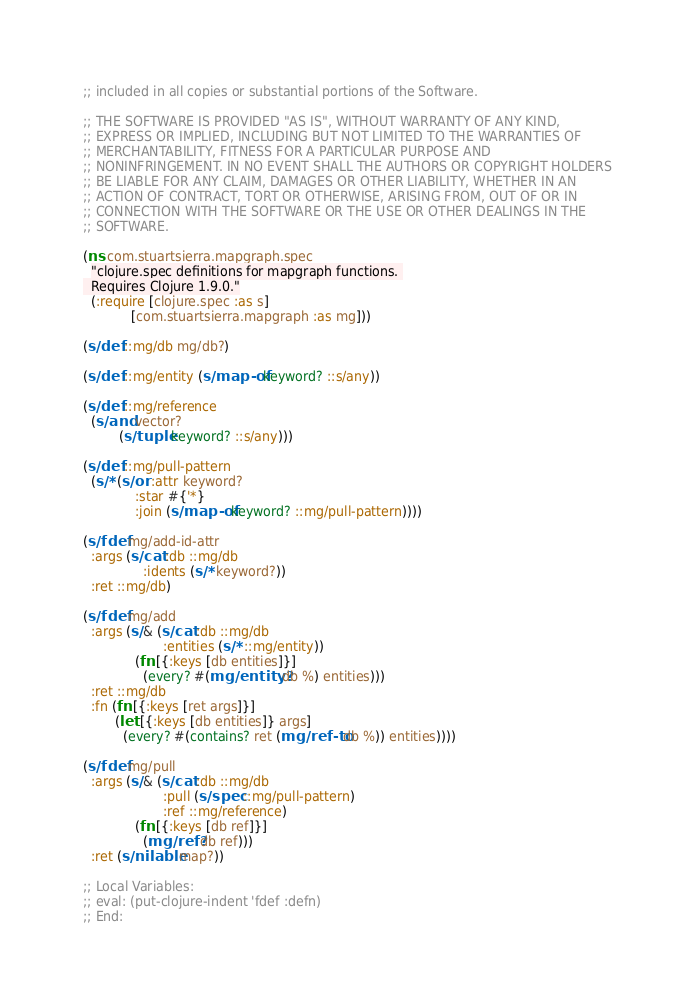<code> <loc_0><loc_0><loc_500><loc_500><_Clojure_>;; included in all copies or substantial portions of the Software.

;; THE SOFTWARE IS PROVIDED "AS IS", WITHOUT WARRANTY OF ANY KIND,
;; EXPRESS OR IMPLIED, INCLUDING BUT NOT LIMITED TO THE WARRANTIES OF
;; MERCHANTABILITY, FITNESS FOR A PARTICULAR PURPOSE AND
;; NONINFRINGEMENT. IN NO EVENT SHALL THE AUTHORS OR COPYRIGHT HOLDERS
;; BE LIABLE FOR ANY CLAIM, DAMAGES OR OTHER LIABILITY, WHETHER IN AN
;; ACTION OF CONTRACT, TORT OR OTHERWISE, ARISING FROM, OUT OF OR IN
;; CONNECTION WITH THE SOFTWARE OR THE USE OR OTHER DEALINGS IN THE
;; SOFTWARE.

(ns com.stuartsierra.mapgraph.spec
  "clojure.spec definitions for mapgraph functions. 
  Requires Clojure 1.9.0."
  (:require [clojure.spec :as s]
            [com.stuartsierra.mapgraph :as mg]))

(s/def ::mg/db mg/db?)

(s/def ::mg/entity (s/map-of keyword? ::s/any))

(s/def ::mg/reference
  (s/and vector?
         (s/tuple keyword? ::s/any)))

(s/def ::mg/pull-pattern
  (s/* (s/or :attr keyword?
             :star #{'*}
             :join (s/map-of keyword? ::mg/pull-pattern))))

(s/fdef mg/add-id-attr
  :args (s/cat :db ::mg/db
               :idents (s/* keyword?))
  :ret ::mg/db)

(s/fdef mg/add
  :args (s/& (s/cat :db ::mg/db
                    :entities (s/* ::mg/entity))
             (fn [{:keys [db entities]}]
               (every? #(mg/entity? db %) entities)))
  :ret ::mg/db
  :fn (fn [{:keys [ret args]}]
        (let [{:keys [db entities]} args]
          (every? #(contains? ret (mg/ref-to db %)) entities))))

(s/fdef mg/pull
  :args (s/& (s/cat :db ::mg/db
                    :pull (s/spec ::mg/pull-pattern)
                    :ref ::mg/reference)
             (fn [{:keys [db ref]}]
               (mg/ref? db ref)))
  :ret (s/nilable map?))

;; Local Variables:
;; eval: (put-clojure-indent 'fdef :defn)
;; End:
</code> 